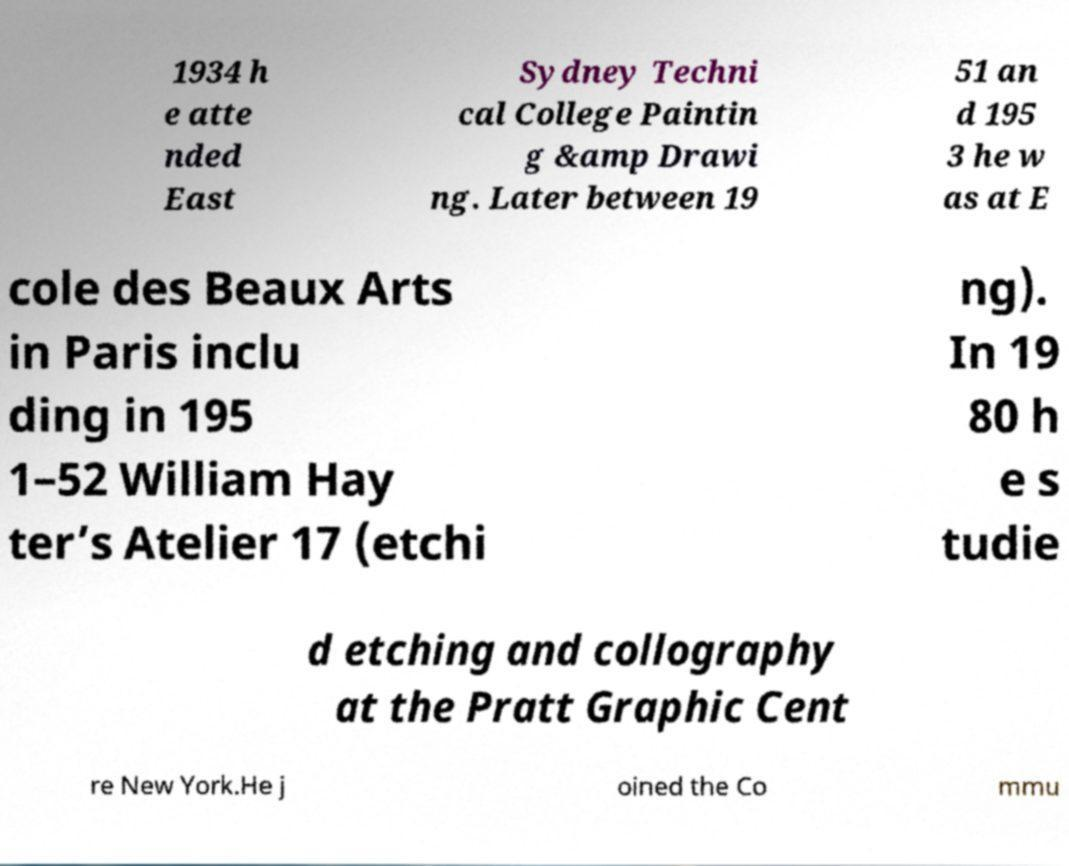What messages or text are displayed in this image? I need them in a readable, typed format. 1934 h e atte nded East Sydney Techni cal College Paintin g &amp Drawi ng. Later between 19 51 an d 195 3 he w as at E cole des Beaux Arts in Paris inclu ding in 195 1–52 William Hay ter’s Atelier 17 (etchi ng). In 19 80 h e s tudie d etching and collography at the Pratt Graphic Cent re New York.He j oined the Co mmu 